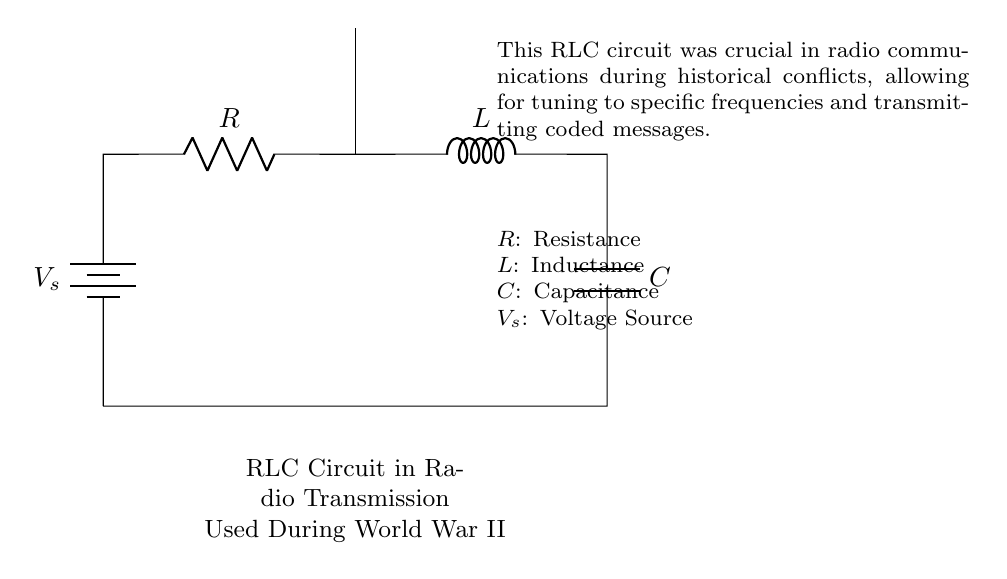What components are present in this RLC circuit? The circuit contains a resistor, inductor, and capacitor, which are standard components in an RLC circuit. Identifying them from the diagram shows a clear representation of each type of component.
Answer: Resistor, inductor, capacitor What is the purpose of this RLC circuit? The primary purpose of the RLC circuit is to allow for tuning to specific frequencies, which is crucial in radio transmission systems for effective communication during conflicts. This functionality supports controlled signal transmission.
Answer: Tuning for communication What does the voltage source represent in this circuit? The voltage source provides the necessary electrical energy for the circuit to operate. It serves as the power supply that enables current to flow through the components, important for activating the radio transmission.
Answer: Power supply What role does the inductor play in radio transmission? The inductor is crucial for storing energy in a magnetic field and influencing the circuit's frequency response, which helps tune to specific frequencies for effective message transmission. Its value affects the circuit's behavior regarding frequency.
Answer: Tuning and energy storage How does this circuit facilitate radio communication during conflicts? The RLC circuit facilitates radio communication by allowing modulation and demodulation of signals, essential for transmitting coded messages, especially in situations like World War II where effective communication was critical. The combination of resistance, inductance, and capacitance enables this functionality.
Answer: Modulation of signals What happens if the capacitor is removed from the circuit? Removing the capacitor would significantly alter the circuit’s ability to filter and store energy, destabilizing the frequency tuning and reducing the effectiveness of the radio transmission. The circuit would not function as intended, making it critical for communication.
Answer: Loss of tuning stability 